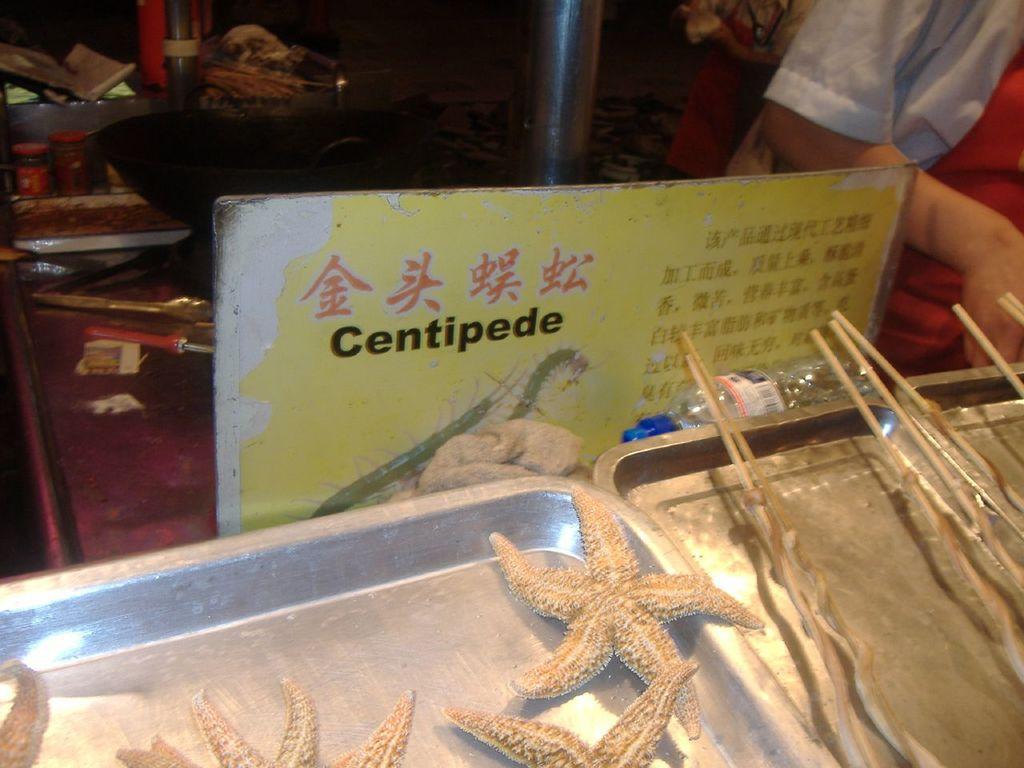Could you give a brief overview of what you see in this image? In this image we can see steel objects, board with text, food items and we can also see a human hand. 